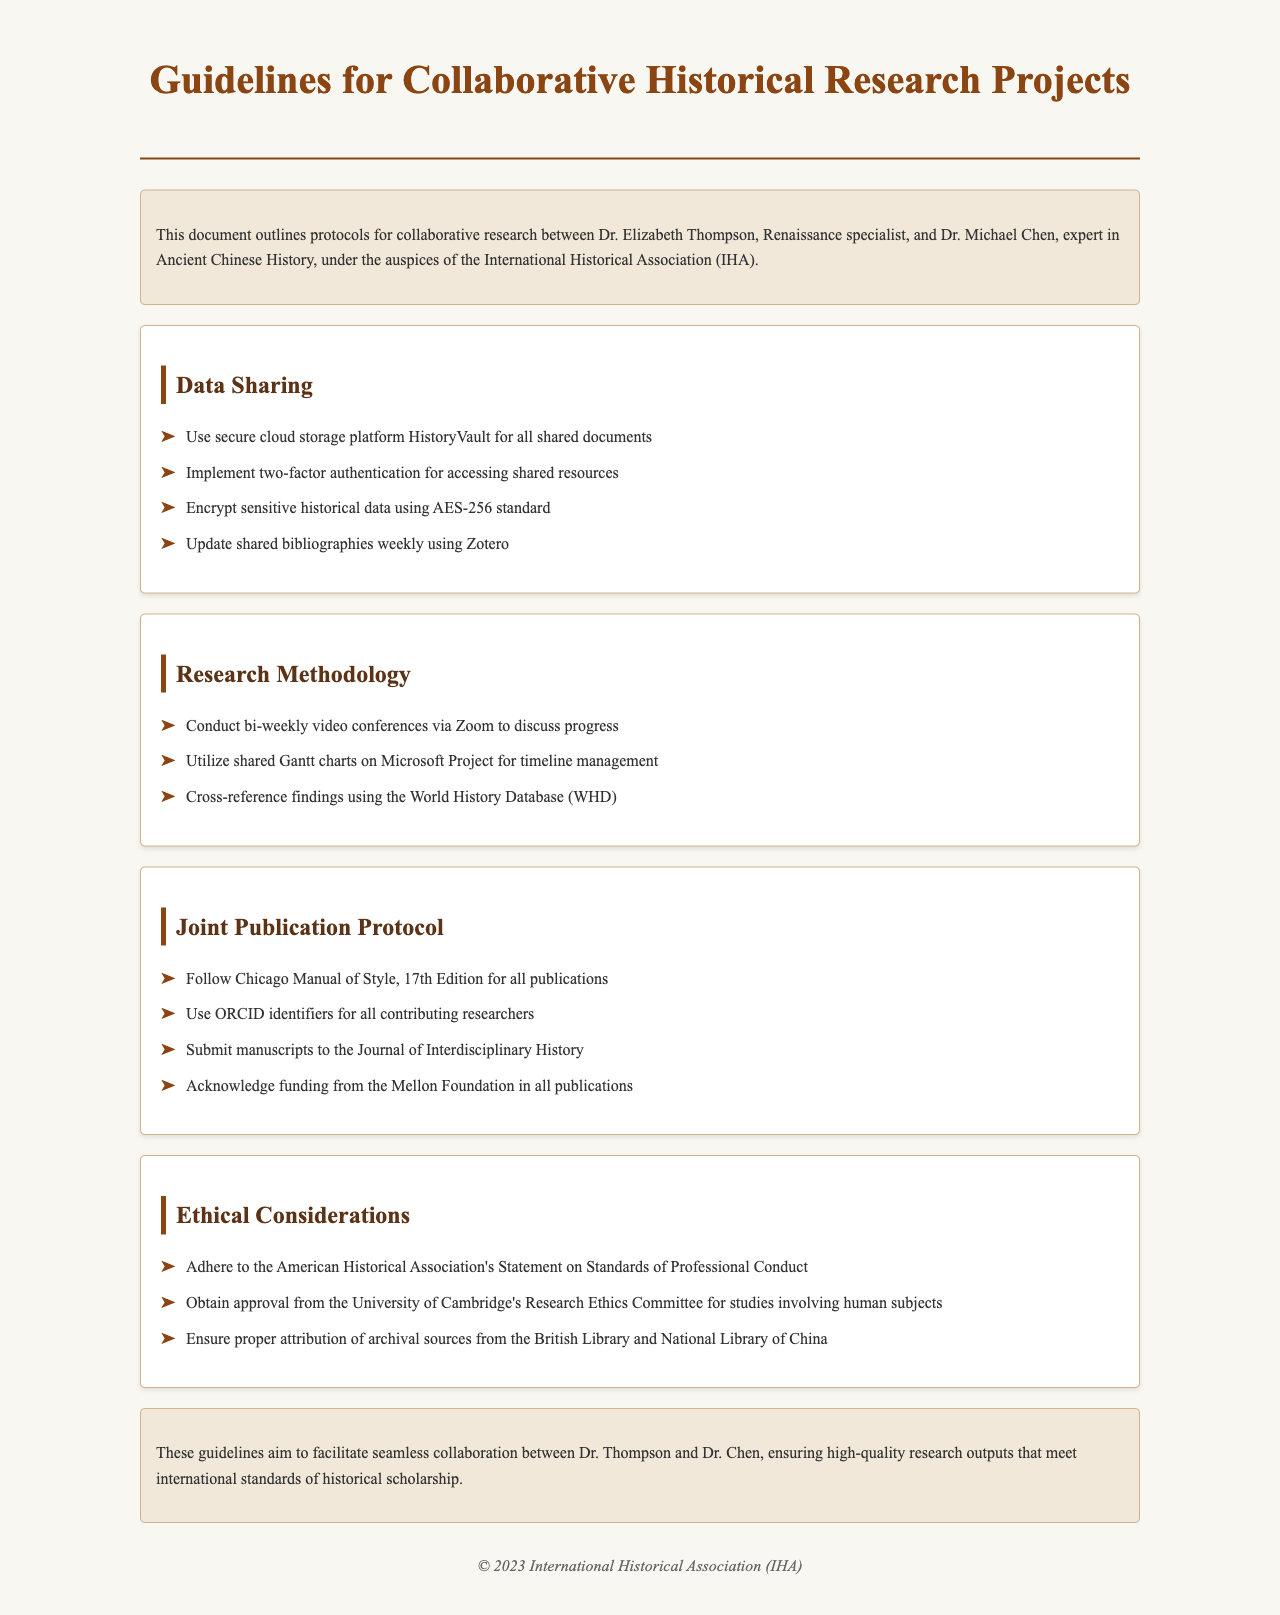What is the document's title? The title is provided in the header section of the document, stating the purpose of the guidelines.
Answer: Guidelines for Collaborative Historical Research Projects Who are the collaborating historians mentioned? The document introduces the two historians who will be collaborating on research, listed in the introduction.
Answer: Dr. Elizabeth Thompson and Dr. Michael Chen What platform is used for data sharing? The specific secure platform for data sharing is mentioned under the Data Sharing section.
Answer: HistoryVault What standard is used for data encryption? The encryption method for sensitive data is stated in the Data Sharing section.
Answer: AES-256 What style guide is followed for publications? The Joint Publication Protocol section specifies the style guide to be used for all publications.
Answer: Chicago Manual of Style, 17th Edition How often should bibliographies be updated? The frequency of bibliography updates is clearly defined in the Data Sharing section.
Answer: Weekly What is the requirement for studies involving human subjects? The Ethical Considerations section outlines the necessary approval for such studies.
Answer: Approval from the University of Cambridge's Research Ethics Committee Where should manuscripts be submitted? The document specifies the destination for manuscript submissions in the Joint Publication Protocol section.
Answer: Journal of Interdisciplinary History What document sets the professional conduct standards? The Ethical Considerations section names the association whose statement is to be followed.
Answer: American Historical Association's Statement on Standards of Professional Conduct 